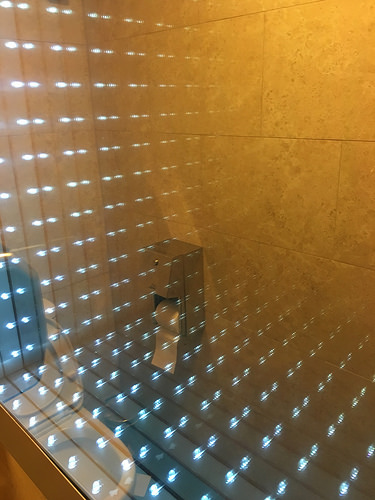<image>
Is the toilet paper to the right of the toilet? No. The toilet paper is not to the right of the toilet. The horizontal positioning shows a different relationship. 